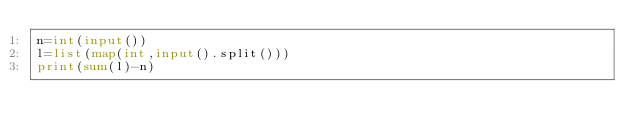<code> <loc_0><loc_0><loc_500><loc_500><_Python_>n=int(input())
l=list(map(int,input().split()))
print(sum(l)-n)</code> 